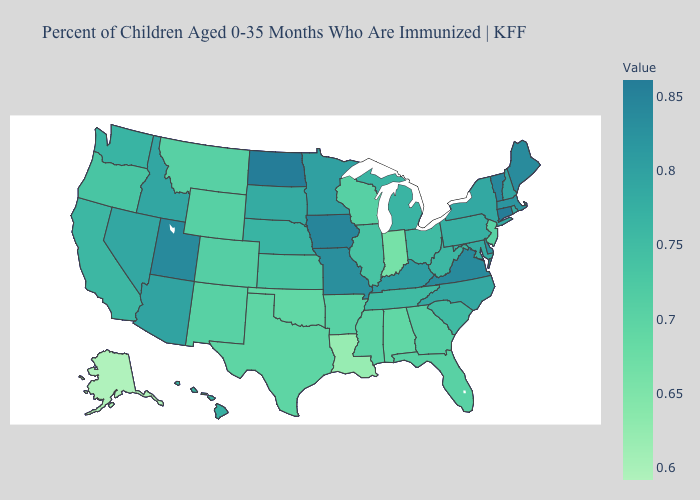Does the map have missing data?
Quick response, please. No. Does Alaska have the lowest value in the USA?
Write a very short answer. Yes. Among the states that border Florida , which have the lowest value?
Concise answer only. Alabama. Does Alaska have the lowest value in the USA?
Keep it brief. Yes. 